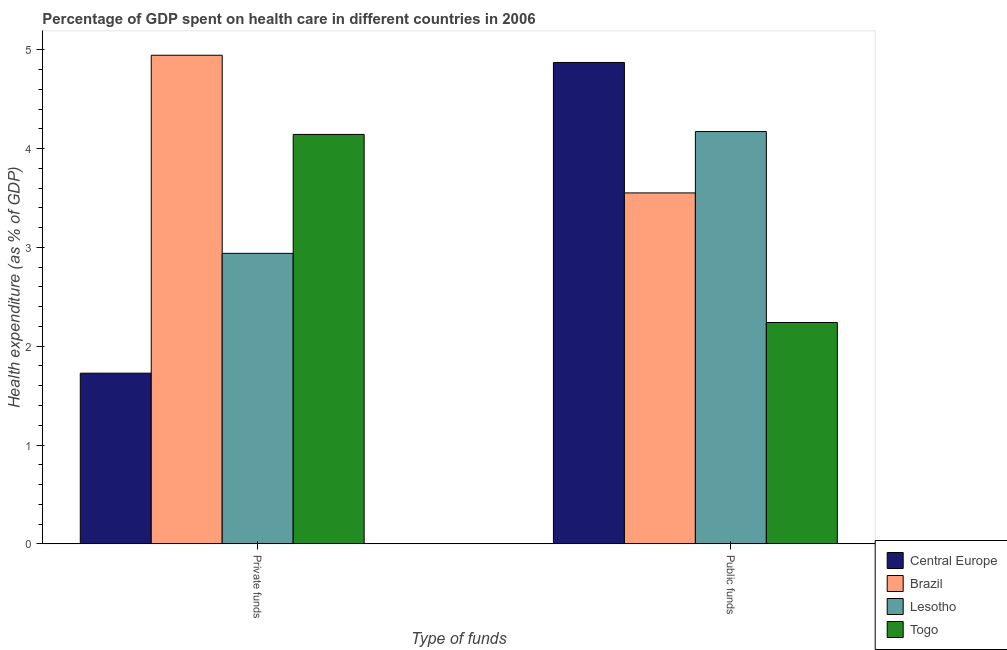How many different coloured bars are there?
Offer a terse response. 4. Are the number of bars per tick equal to the number of legend labels?
Make the answer very short. Yes. Are the number of bars on each tick of the X-axis equal?
Provide a succinct answer. Yes. How many bars are there on the 2nd tick from the left?
Provide a short and direct response. 4. How many bars are there on the 1st tick from the right?
Give a very brief answer. 4. What is the label of the 2nd group of bars from the left?
Provide a succinct answer. Public funds. What is the amount of public funds spent in healthcare in Central Europe?
Keep it short and to the point. 4.87. Across all countries, what is the maximum amount of private funds spent in healthcare?
Your answer should be compact. 4.95. Across all countries, what is the minimum amount of private funds spent in healthcare?
Your response must be concise. 1.73. In which country was the amount of public funds spent in healthcare maximum?
Provide a short and direct response. Central Europe. In which country was the amount of public funds spent in healthcare minimum?
Make the answer very short. Togo. What is the total amount of public funds spent in healthcare in the graph?
Your answer should be very brief. 14.84. What is the difference between the amount of public funds spent in healthcare in Central Europe and that in Togo?
Provide a short and direct response. 2.63. What is the difference between the amount of public funds spent in healthcare in Brazil and the amount of private funds spent in healthcare in Lesotho?
Make the answer very short. 0.61. What is the average amount of public funds spent in healthcare per country?
Ensure brevity in your answer.  3.71. What is the difference between the amount of private funds spent in healthcare and amount of public funds spent in healthcare in Central Europe?
Make the answer very short. -3.15. In how many countries, is the amount of public funds spent in healthcare greater than 2.4 %?
Your answer should be compact. 3. What is the ratio of the amount of public funds spent in healthcare in Brazil to that in Togo?
Offer a terse response. 1.59. What does the 1st bar from the right in Private funds represents?
Provide a succinct answer. Togo. How many bars are there?
Provide a short and direct response. 8. Are all the bars in the graph horizontal?
Your answer should be compact. No. How many countries are there in the graph?
Ensure brevity in your answer.  4. Are the values on the major ticks of Y-axis written in scientific E-notation?
Ensure brevity in your answer.  No. Does the graph contain grids?
Your answer should be compact. No. Where does the legend appear in the graph?
Your answer should be very brief. Bottom right. How are the legend labels stacked?
Ensure brevity in your answer.  Vertical. What is the title of the graph?
Ensure brevity in your answer.  Percentage of GDP spent on health care in different countries in 2006. What is the label or title of the X-axis?
Your answer should be very brief. Type of funds. What is the label or title of the Y-axis?
Ensure brevity in your answer.  Health expenditure (as % of GDP). What is the Health expenditure (as % of GDP) in Central Europe in Private funds?
Give a very brief answer. 1.73. What is the Health expenditure (as % of GDP) in Brazil in Private funds?
Ensure brevity in your answer.  4.95. What is the Health expenditure (as % of GDP) in Lesotho in Private funds?
Make the answer very short. 2.94. What is the Health expenditure (as % of GDP) of Togo in Private funds?
Your answer should be compact. 4.14. What is the Health expenditure (as % of GDP) of Central Europe in Public funds?
Offer a terse response. 4.87. What is the Health expenditure (as % of GDP) in Brazil in Public funds?
Your answer should be compact. 3.55. What is the Health expenditure (as % of GDP) in Lesotho in Public funds?
Provide a short and direct response. 4.17. What is the Health expenditure (as % of GDP) of Togo in Public funds?
Make the answer very short. 2.24. Across all Type of funds, what is the maximum Health expenditure (as % of GDP) of Central Europe?
Provide a succinct answer. 4.87. Across all Type of funds, what is the maximum Health expenditure (as % of GDP) in Brazil?
Offer a very short reply. 4.95. Across all Type of funds, what is the maximum Health expenditure (as % of GDP) of Lesotho?
Ensure brevity in your answer.  4.17. Across all Type of funds, what is the maximum Health expenditure (as % of GDP) in Togo?
Your response must be concise. 4.14. Across all Type of funds, what is the minimum Health expenditure (as % of GDP) of Central Europe?
Ensure brevity in your answer.  1.73. Across all Type of funds, what is the minimum Health expenditure (as % of GDP) in Brazil?
Provide a succinct answer. 3.55. Across all Type of funds, what is the minimum Health expenditure (as % of GDP) of Lesotho?
Make the answer very short. 2.94. Across all Type of funds, what is the minimum Health expenditure (as % of GDP) in Togo?
Offer a very short reply. 2.24. What is the total Health expenditure (as % of GDP) in Central Europe in the graph?
Offer a very short reply. 6.6. What is the total Health expenditure (as % of GDP) of Brazil in the graph?
Your answer should be compact. 8.5. What is the total Health expenditure (as % of GDP) of Lesotho in the graph?
Ensure brevity in your answer.  7.11. What is the total Health expenditure (as % of GDP) of Togo in the graph?
Your response must be concise. 6.38. What is the difference between the Health expenditure (as % of GDP) in Central Europe in Private funds and that in Public funds?
Keep it short and to the point. -3.15. What is the difference between the Health expenditure (as % of GDP) in Brazil in Private funds and that in Public funds?
Your response must be concise. 1.39. What is the difference between the Health expenditure (as % of GDP) in Lesotho in Private funds and that in Public funds?
Offer a terse response. -1.23. What is the difference between the Health expenditure (as % of GDP) of Togo in Private funds and that in Public funds?
Offer a very short reply. 1.9. What is the difference between the Health expenditure (as % of GDP) of Central Europe in Private funds and the Health expenditure (as % of GDP) of Brazil in Public funds?
Keep it short and to the point. -1.82. What is the difference between the Health expenditure (as % of GDP) in Central Europe in Private funds and the Health expenditure (as % of GDP) in Lesotho in Public funds?
Your answer should be very brief. -2.45. What is the difference between the Health expenditure (as % of GDP) of Central Europe in Private funds and the Health expenditure (as % of GDP) of Togo in Public funds?
Give a very brief answer. -0.51. What is the difference between the Health expenditure (as % of GDP) of Brazil in Private funds and the Health expenditure (as % of GDP) of Lesotho in Public funds?
Keep it short and to the point. 0.77. What is the difference between the Health expenditure (as % of GDP) of Brazil in Private funds and the Health expenditure (as % of GDP) of Togo in Public funds?
Your answer should be compact. 2.71. What is the difference between the Health expenditure (as % of GDP) in Lesotho in Private funds and the Health expenditure (as % of GDP) in Togo in Public funds?
Your response must be concise. 0.7. What is the average Health expenditure (as % of GDP) of Central Europe per Type of funds?
Make the answer very short. 3.3. What is the average Health expenditure (as % of GDP) of Brazil per Type of funds?
Your answer should be very brief. 4.25. What is the average Health expenditure (as % of GDP) in Lesotho per Type of funds?
Keep it short and to the point. 3.56. What is the average Health expenditure (as % of GDP) in Togo per Type of funds?
Offer a terse response. 3.19. What is the difference between the Health expenditure (as % of GDP) in Central Europe and Health expenditure (as % of GDP) in Brazil in Private funds?
Ensure brevity in your answer.  -3.22. What is the difference between the Health expenditure (as % of GDP) of Central Europe and Health expenditure (as % of GDP) of Lesotho in Private funds?
Keep it short and to the point. -1.21. What is the difference between the Health expenditure (as % of GDP) of Central Europe and Health expenditure (as % of GDP) of Togo in Private funds?
Your response must be concise. -2.42. What is the difference between the Health expenditure (as % of GDP) of Brazil and Health expenditure (as % of GDP) of Lesotho in Private funds?
Keep it short and to the point. 2.01. What is the difference between the Health expenditure (as % of GDP) in Brazil and Health expenditure (as % of GDP) in Togo in Private funds?
Your answer should be very brief. 0.8. What is the difference between the Health expenditure (as % of GDP) of Lesotho and Health expenditure (as % of GDP) of Togo in Private funds?
Ensure brevity in your answer.  -1.2. What is the difference between the Health expenditure (as % of GDP) of Central Europe and Health expenditure (as % of GDP) of Brazil in Public funds?
Keep it short and to the point. 1.32. What is the difference between the Health expenditure (as % of GDP) in Central Europe and Health expenditure (as % of GDP) in Lesotho in Public funds?
Offer a terse response. 0.7. What is the difference between the Health expenditure (as % of GDP) of Central Europe and Health expenditure (as % of GDP) of Togo in Public funds?
Keep it short and to the point. 2.63. What is the difference between the Health expenditure (as % of GDP) in Brazil and Health expenditure (as % of GDP) in Lesotho in Public funds?
Your answer should be very brief. -0.62. What is the difference between the Health expenditure (as % of GDP) in Brazil and Health expenditure (as % of GDP) in Togo in Public funds?
Give a very brief answer. 1.31. What is the difference between the Health expenditure (as % of GDP) in Lesotho and Health expenditure (as % of GDP) in Togo in Public funds?
Provide a succinct answer. 1.93. What is the ratio of the Health expenditure (as % of GDP) of Central Europe in Private funds to that in Public funds?
Make the answer very short. 0.35. What is the ratio of the Health expenditure (as % of GDP) of Brazil in Private funds to that in Public funds?
Provide a short and direct response. 1.39. What is the ratio of the Health expenditure (as % of GDP) in Lesotho in Private funds to that in Public funds?
Provide a short and direct response. 0.7. What is the ratio of the Health expenditure (as % of GDP) in Togo in Private funds to that in Public funds?
Keep it short and to the point. 1.85. What is the difference between the highest and the second highest Health expenditure (as % of GDP) of Central Europe?
Your response must be concise. 3.15. What is the difference between the highest and the second highest Health expenditure (as % of GDP) in Brazil?
Provide a succinct answer. 1.39. What is the difference between the highest and the second highest Health expenditure (as % of GDP) of Lesotho?
Give a very brief answer. 1.23. What is the difference between the highest and the second highest Health expenditure (as % of GDP) of Togo?
Offer a very short reply. 1.9. What is the difference between the highest and the lowest Health expenditure (as % of GDP) in Central Europe?
Ensure brevity in your answer.  3.15. What is the difference between the highest and the lowest Health expenditure (as % of GDP) of Brazil?
Offer a very short reply. 1.39. What is the difference between the highest and the lowest Health expenditure (as % of GDP) in Lesotho?
Offer a very short reply. 1.23. What is the difference between the highest and the lowest Health expenditure (as % of GDP) in Togo?
Your answer should be compact. 1.9. 